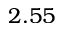<formula> <loc_0><loc_0><loc_500><loc_500>2 . 5 5</formula> 